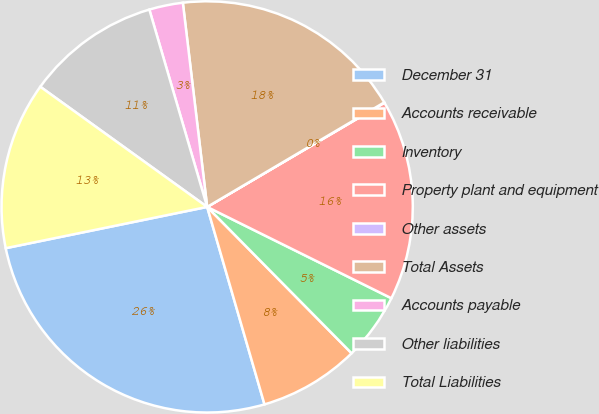<chart> <loc_0><loc_0><loc_500><loc_500><pie_chart><fcel>December 31<fcel>Accounts receivable<fcel>Inventory<fcel>Property plant and equipment<fcel>Other assets<fcel>Total Assets<fcel>Accounts payable<fcel>Other liabilities<fcel>Total Liabilities<nl><fcel>26.28%<fcel>7.9%<fcel>5.28%<fcel>15.78%<fcel>0.03%<fcel>18.4%<fcel>2.65%<fcel>10.53%<fcel>13.15%<nl></chart> 